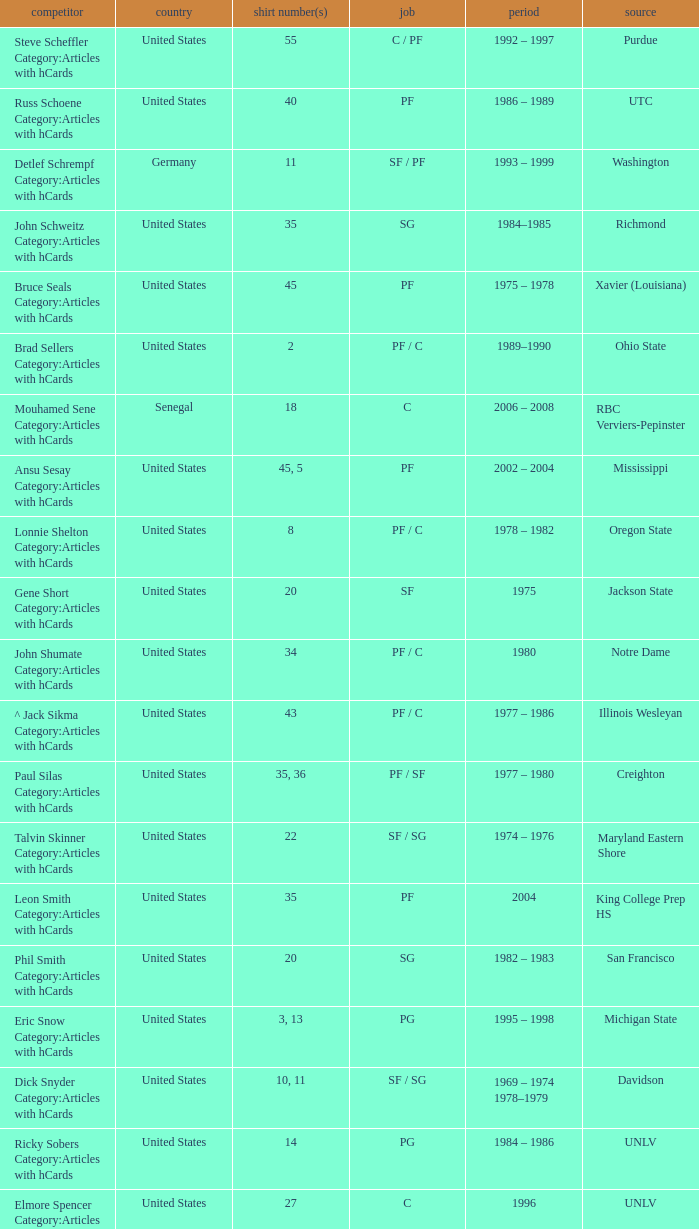Would you be able to parse every entry in this table? {'header': ['competitor', 'country', 'shirt number(s)', 'job', 'period', 'source'], 'rows': [['Steve Scheffler Category:Articles with hCards', 'United States', '55', 'C / PF', '1992 – 1997', 'Purdue'], ['Russ Schoene Category:Articles with hCards', 'United States', '40', 'PF', '1986 – 1989', 'UTC'], ['Detlef Schrempf Category:Articles with hCards', 'Germany', '11', 'SF / PF', '1993 – 1999', 'Washington'], ['John Schweitz Category:Articles with hCards', 'United States', '35', 'SG', '1984–1985', 'Richmond'], ['Bruce Seals Category:Articles with hCards', 'United States', '45', 'PF', '1975 – 1978', 'Xavier (Louisiana)'], ['Brad Sellers Category:Articles with hCards', 'United States', '2', 'PF / C', '1989–1990', 'Ohio State'], ['Mouhamed Sene Category:Articles with hCards', 'Senegal', '18', 'C', '2006 – 2008', 'RBC Verviers-Pepinster'], ['Ansu Sesay Category:Articles with hCards', 'United States', '45, 5', 'PF', '2002 – 2004', 'Mississippi'], ['Lonnie Shelton Category:Articles with hCards', 'United States', '8', 'PF / C', '1978 – 1982', 'Oregon State'], ['Gene Short Category:Articles with hCards', 'United States', '20', 'SF', '1975', 'Jackson State'], ['John Shumate Category:Articles with hCards', 'United States', '34', 'PF / C', '1980', 'Notre Dame'], ['^ Jack Sikma Category:Articles with hCards', 'United States', '43', 'PF / C', '1977 – 1986', 'Illinois Wesleyan'], ['Paul Silas Category:Articles with hCards', 'United States', '35, 36', 'PF / SF', '1977 – 1980', 'Creighton'], ['Talvin Skinner Category:Articles with hCards', 'United States', '22', 'SF / SG', '1974 – 1976', 'Maryland Eastern Shore'], ['Leon Smith Category:Articles with hCards', 'United States', '35', 'PF', '2004', 'King College Prep HS'], ['Phil Smith Category:Articles with hCards', 'United States', '20', 'SG', '1982 – 1983', 'San Francisco'], ['Eric Snow Category:Articles with hCards', 'United States', '3, 13', 'PG', '1995 – 1998', 'Michigan State'], ['Dick Snyder Category:Articles with hCards', 'United States', '10, 11', 'SF / SG', '1969 – 1974 1978–1979', 'Davidson'], ['Ricky Sobers Category:Articles with hCards', 'United States', '14', 'PG', '1984 – 1986', 'UNLV'], ['Elmore Spencer Category:Articles with hCards', 'United States', '27', 'C', '1996', 'UNLV'], ['Isaac Stallworth Category:Articles with hCards', 'United States', '15', 'SF / SG', '1972 – 1974', 'Kansas'], ['Terence Stansbury Category:Articles with hCards', 'United States', '44', 'SG', '1986–1987', 'Temple'], ['Vladimir Stepania Category:Articles with hCards', 'Georgia', '5', 'Center', '1999 – 2000', 'KK Union Olimpija'], ['Larry Stewart Category:Articles with hCards', 'United States', '23', 'SF', '1996–1997', 'Coppin State'], ['Alex Stivrins Category:Articles with hCards', 'United States', '42', 'PF', '1985', 'Colorado'], ['Jon Sundvold Category:Articles with hCards', 'United States', '20', 'SG', '1984 – 1985', 'Missouri'], ['Robert Swift Category:Articles with hCards', 'United States', '31', 'C', '2005 – 2008', 'Bakersfield HS'], ['Wally Szczerbiak Category:Articles with hCards', 'United States', '3', 'SF / SG', '2007–2008', 'Miami (Ohio)']]} What position does the player with jersey number 22 play? SF / SG. 